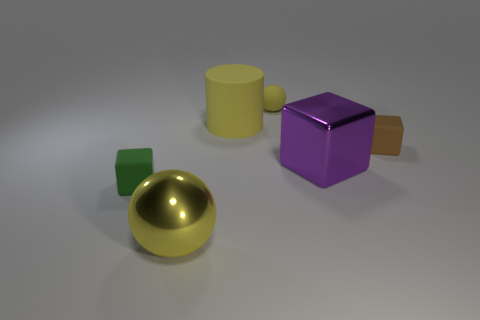Does the big cylinder have the same color as the big ball?
Your response must be concise. Yes. There is a rubber thing that is in front of the tiny yellow rubber thing and behind the brown matte block; what shape is it?
Your answer should be compact. Cylinder. Is the number of yellow rubber cylinders that are to the right of the green rubber thing greater than the number of tiny blue cylinders?
Offer a terse response. Yes. There is a brown cube that is made of the same material as the cylinder; what size is it?
Give a very brief answer. Small. How many cylinders have the same color as the rubber sphere?
Your answer should be compact. 1. There is a big shiny thing in front of the green block; does it have the same color as the large matte thing?
Keep it short and to the point. Yes. Are there an equal number of shiny objects that are in front of the large purple thing and metal spheres in front of the yellow metal ball?
Give a very brief answer. No. There is a small cube right of the big cylinder; what is its color?
Offer a terse response. Brown. Are there the same number of rubber objects behind the big yellow sphere and cyan matte objects?
Give a very brief answer. No. What number of other things are the same shape as the purple shiny thing?
Provide a succinct answer. 2. 